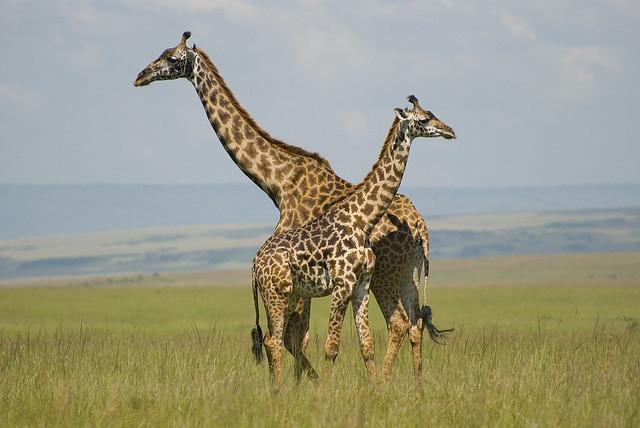How many giraffes can be seen?
Give a very brief answer. 2. How many of these men are wearing glasses?
Give a very brief answer. 0. 